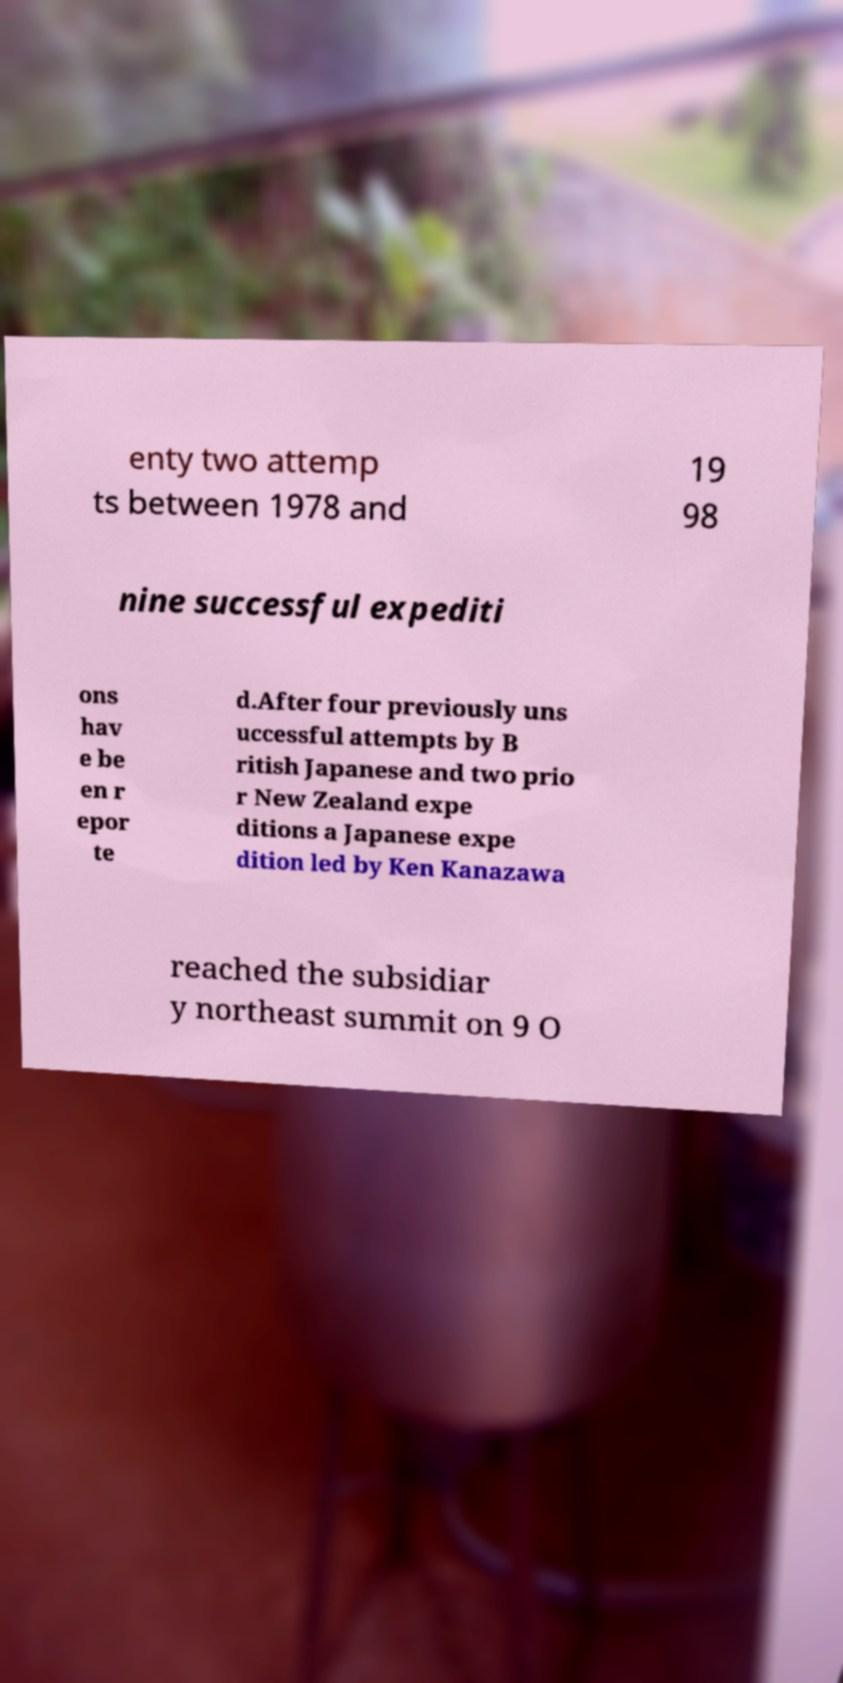Could you assist in decoding the text presented in this image and type it out clearly? enty two attemp ts between 1978 and 19 98 nine successful expediti ons hav e be en r epor te d.After four previously uns uccessful attempts by B ritish Japanese and two prio r New Zealand expe ditions a Japanese expe dition led by Ken Kanazawa reached the subsidiar y northeast summit on 9 O 